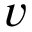Convert formula to latex. <formula><loc_0><loc_0><loc_500><loc_500>v</formula> 